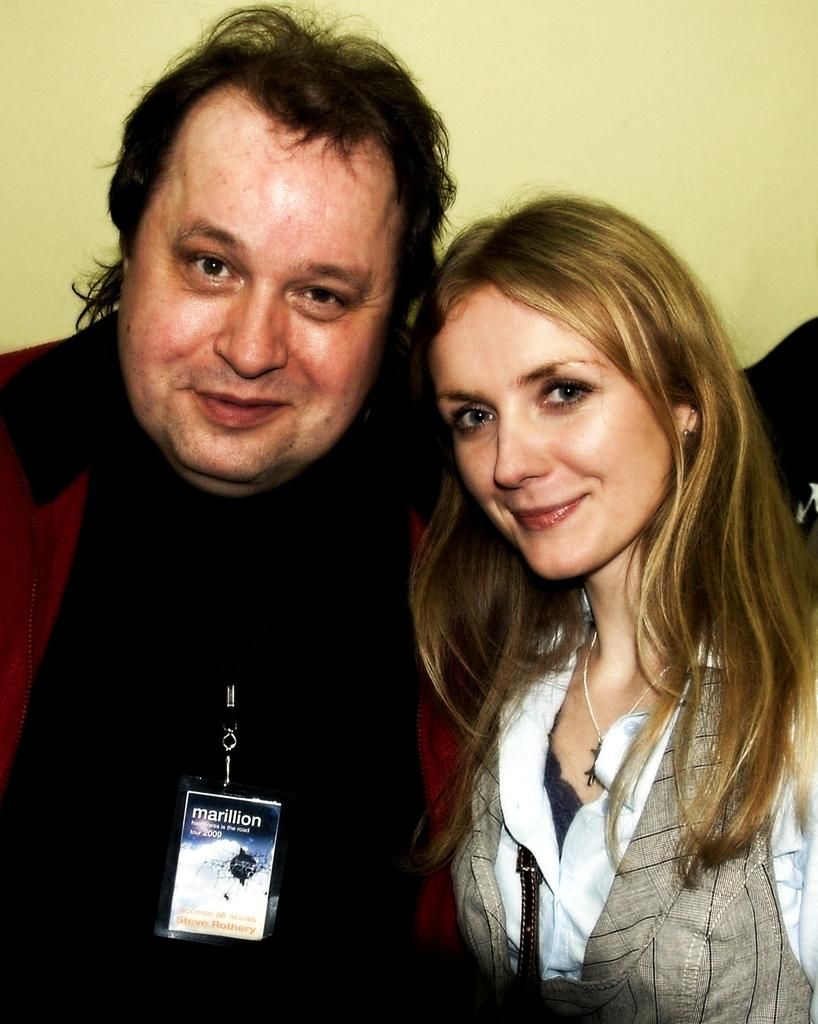Who is present in the image? There is a man and a woman in the image. What are the expressions on their faces? Both the man and woman are smiling in the image. What can be seen on the man or woman? There is a badge visible in the image. What is the color of the background in the image? The background of the image appears to be light yellow in color. Can you hear the whistle in the image? There is no whistle present in the image, so it cannot be heard. What type of eggnog is being served in the image? There is no eggnog present in the image. 